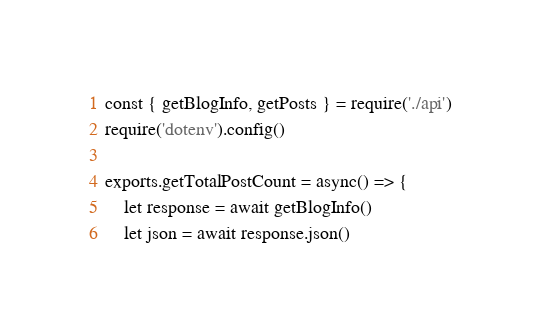Convert code to text. <code><loc_0><loc_0><loc_500><loc_500><_JavaScript_>const { getBlogInfo, getPosts } = require('./api')
require('dotenv').config()

exports.getTotalPostCount = async() => {
    let response = await getBlogInfo()
    let json = await response.json()</code> 